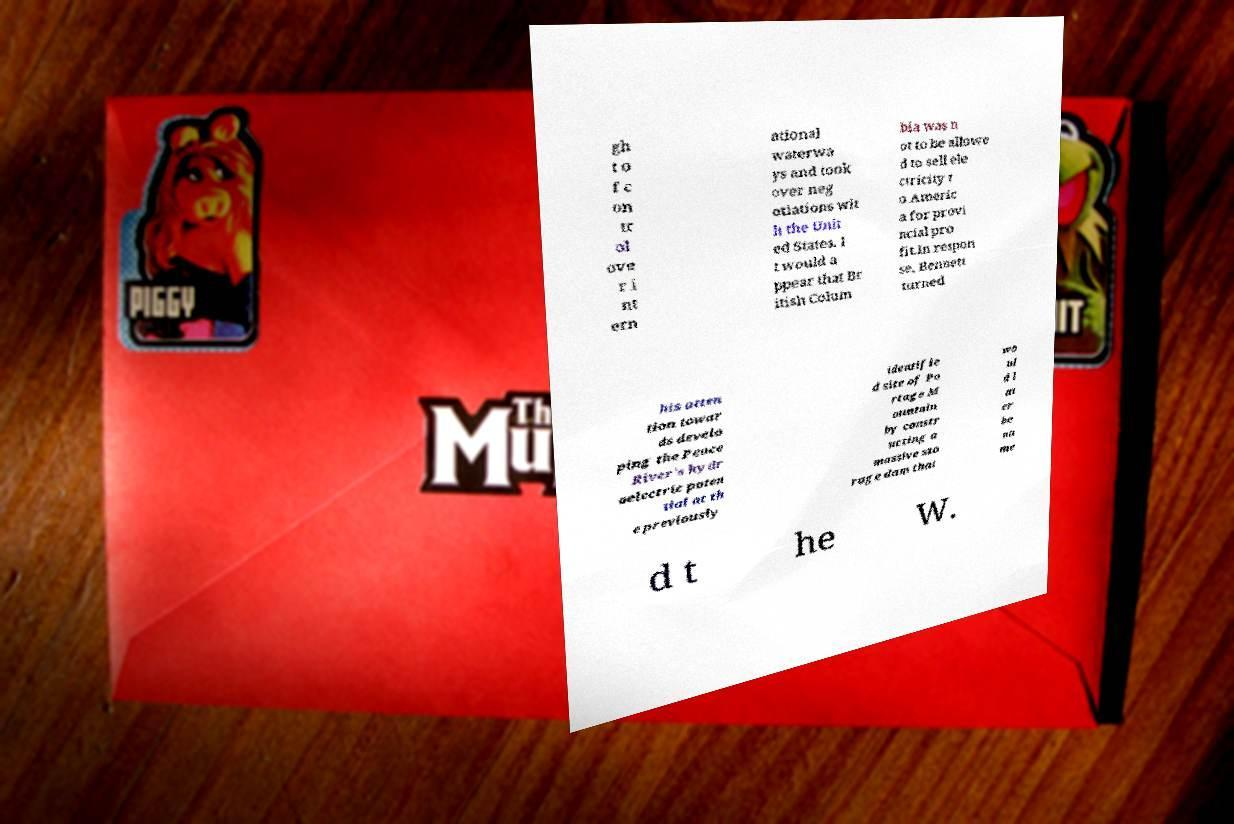Please read and relay the text visible in this image. What does it say? gh t o f c on tr ol ove r i nt ern ational waterwa ys and took over neg otiations wit h the Unit ed States. I t would a ppear that Br itish Colum bia was n ot to be allowe d to sell ele ctricity t o Americ a for provi ncial pro fit.In respon se, Bennett turned his atten tion towar ds develo ping the Peace River's hydr oelectric poten tial at th e previously identifie d site of Po rtage M ountain by constr ucting a massive sto rage dam that wo ul d l at er be na me d t he W. 